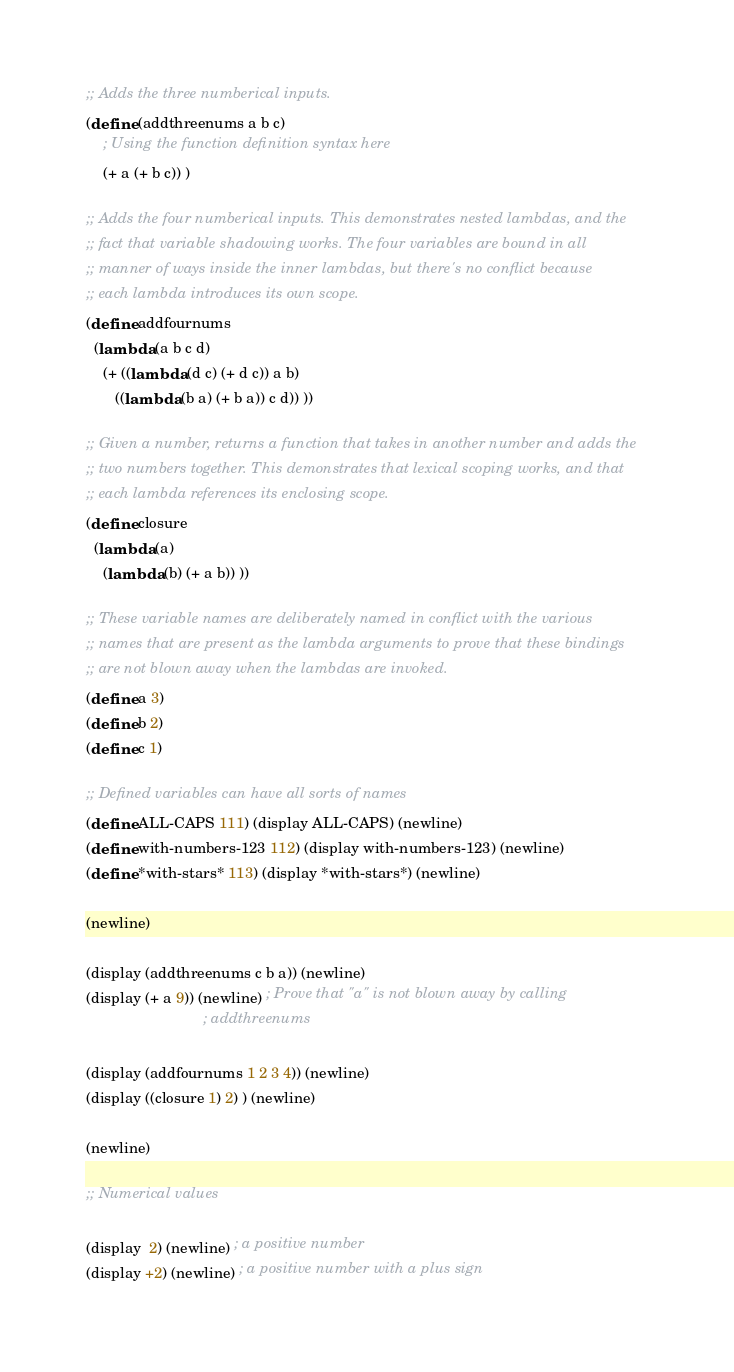Convert code to text. <code><loc_0><loc_0><loc_500><loc_500><_Scheme_>;; Adds the three numberical inputs.
(define (addthreenums a b c)
    ; Using the function definition syntax here
    (+ a (+ b c)) )

;; Adds the four numberical inputs. This demonstrates nested lambdas, and the
;; fact that variable shadowing works. The four variables are bound in all
;; manner of ways inside the inner lambdas, but there's no conflict because
;; each lambda introduces its own scope.
(define addfournums
  (lambda (a b c d)
    (+ ((lambda (d c) (+ d c)) a b)
       ((lambda (b a) (+ b a)) c d)) ))

;; Given a number, returns a function that takes in another number and adds the
;; two numbers together. This demonstrates that lexical scoping works, and that
;; each lambda references its enclosing scope.
(define closure
  (lambda (a)
    (lambda (b) (+ a b)) ))

;; These variable names are deliberately named in conflict with the various
;; names that are present as the lambda arguments to prove that these bindings
;; are not blown away when the lambdas are invoked.
(define a 3)
(define b 2)
(define c 1)

;; Defined variables can have all sorts of names
(define ALL-CAPS 111) (display ALL-CAPS) (newline)
(define with-numbers-123 112) (display with-numbers-123) (newline)
(define *with-stars* 113) (display *with-stars*) (newline)

(newline)

(display (addthreenums c b a)) (newline)
(display (+ a 9)) (newline) ; Prove that "a" is not blown away by calling
                            ; addthreenums

(display (addfournums 1 2 3 4)) (newline)
(display ((closure 1) 2) ) (newline)

(newline)

;; Numerical values

(display  2) (newline) ; a positive number
(display +2) (newline) ; a positive number with a plus sign</code> 